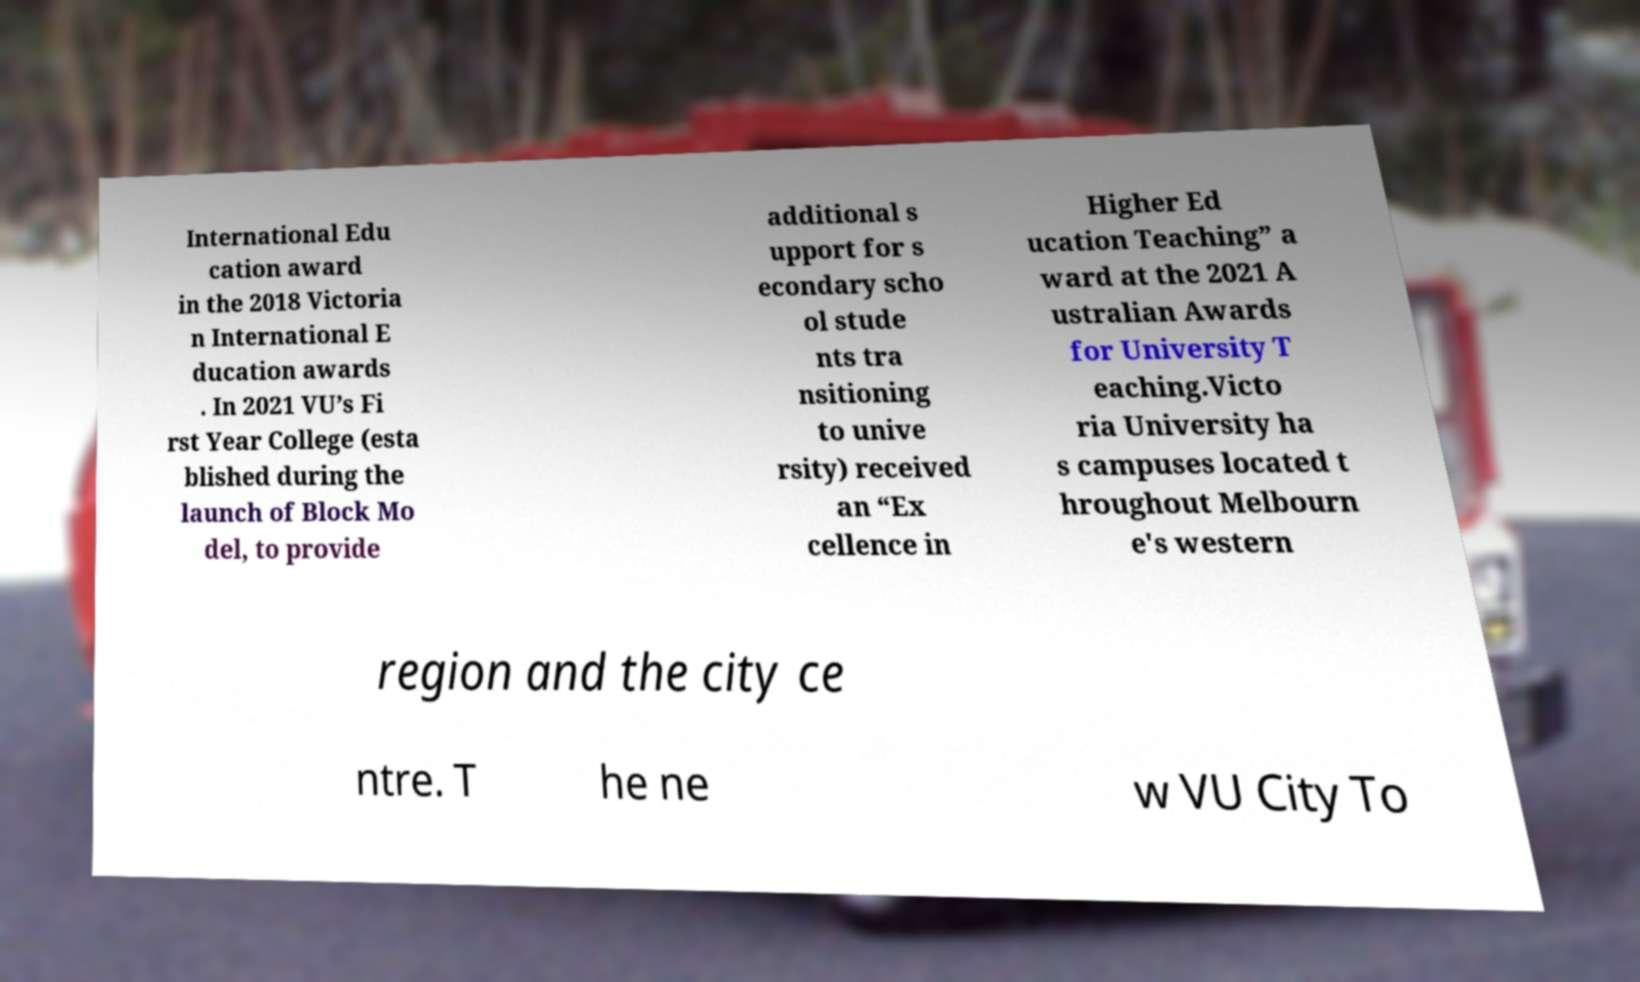Can you read and provide the text displayed in the image?This photo seems to have some interesting text. Can you extract and type it out for me? International Edu cation award in the 2018 Victoria n International E ducation awards . In 2021 VU’s Fi rst Year College (esta blished during the launch of Block Mo del, to provide additional s upport for s econdary scho ol stude nts tra nsitioning to unive rsity) received an “Ex cellence in Higher Ed ucation Teaching” a ward at the 2021 A ustralian Awards for University T eaching.Victo ria University ha s campuses located t hroughout Melbourn e's western region and the city ce ntre. T he ne w VU City To 